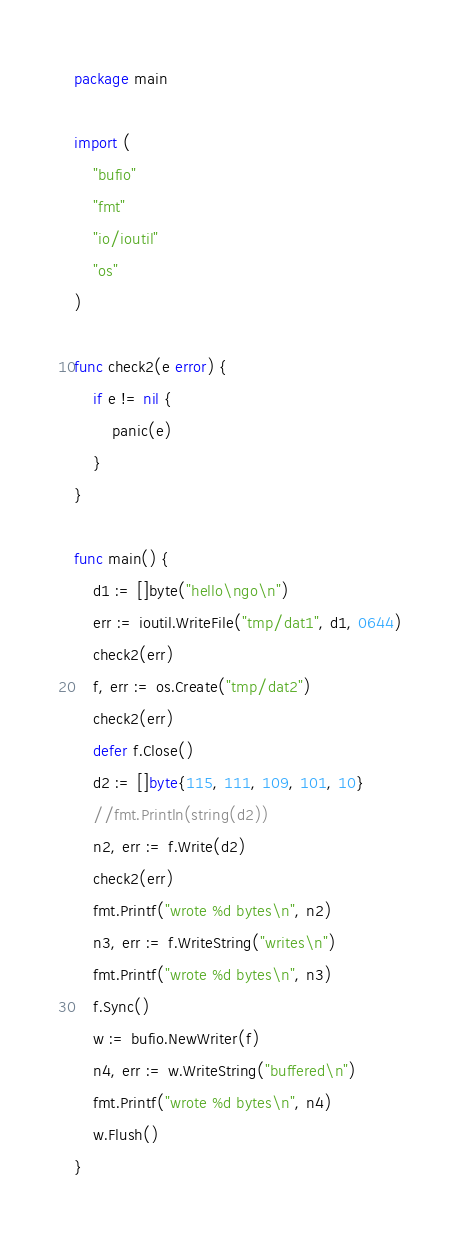Convert code to text. <code><loc_0><loc_0><loc_500><loc_500><_Go_>package main

import (
	"bufio"
	"fmt"
	"io/ioutil"
	"os"
)

func check2(e error) {
	if e != nil {
		panic(e)
	}
}

func main() {
	d1 := []byte("hello\ngo\n")
	err := ioutil.WriteFile("tmp/dat1", d1, 0644)
	check2(err)
	f, err := os.Create("tmp/dat2")
	check2(err)
	defer f.Close()
	d2 := []byte{115, 111, 109, 101, 10}
	//fmt.Println(string(d2))
	n2, err := f.Write(d2)
	check2(err)
	fmt.Printf("wrote %d bytes\n", n2)
	n3, err := f.WriteString("writes\n")
	fmt.Printf("wrote %d bytes\n", n3)
	f.Sync()
	w := bufio.NewWriter(f)
	n4, err := w.WriteString("buffered\n")
	fmt.Printf("wrote %d bytes\n", n4)
	w.Flush()
}
</code> 